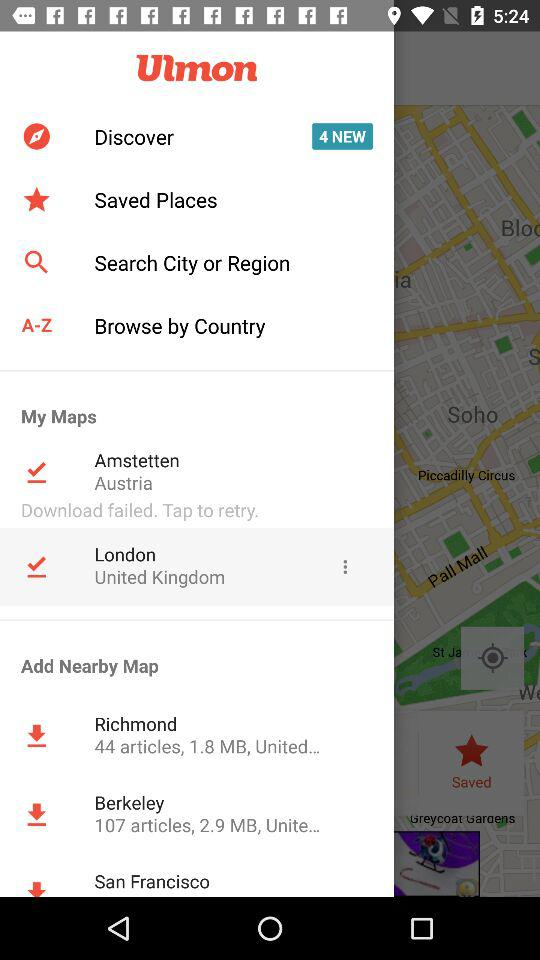What is the organization name? The name of the organization is "Ulmon". 